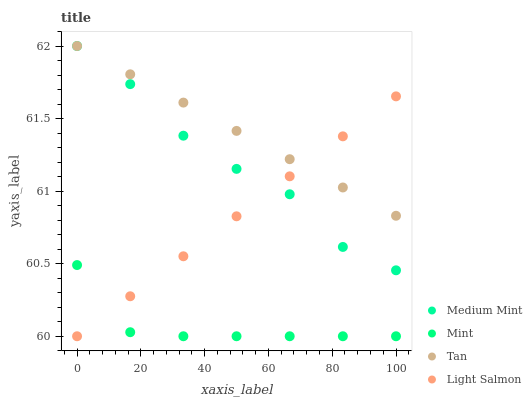Does Mint have the minimum area under the curve?
Answer yes or no. Yes. Does Tan have the maximum area under the curve?
Answer yes or no. Yes. Does Tan have the minimum area under the curve?
Answer yes or no. No. Does Mint have the maximum area under the curve?
Answer yes or no. No. Is Light Salmon the smoothest?
Answer yes or no. Yes. Is Medium Mint the roughest?
Answer yes or no. Yes. Is Tan the smoothest?
Answer yes or no. No. Is Tan the roughest?
Answer yes or no. No. Does Mint have the lowest value?
Answer yes or no. Yes. Does Tan have the lowest value?
Answer yes or no. No. Does Tan have the highest value?
Answer yes or no. Yes. Does Mint have the highest value?
Answer yes or no. No. Is Mint less than Tan?
Answer yes or no. Yes. Is Medium Mint greater than Mint?
Answer yes or no. Yes. Does Tan intersect Light Salmon?
Answer yes or no. Yes. Is Tan less than Light Salmon?
Answer yes or no. No. Is Tan greater than Light Salmon?
Answer yes or no. No. Does Mint intersect Tan?
Answer yes or no. No. 